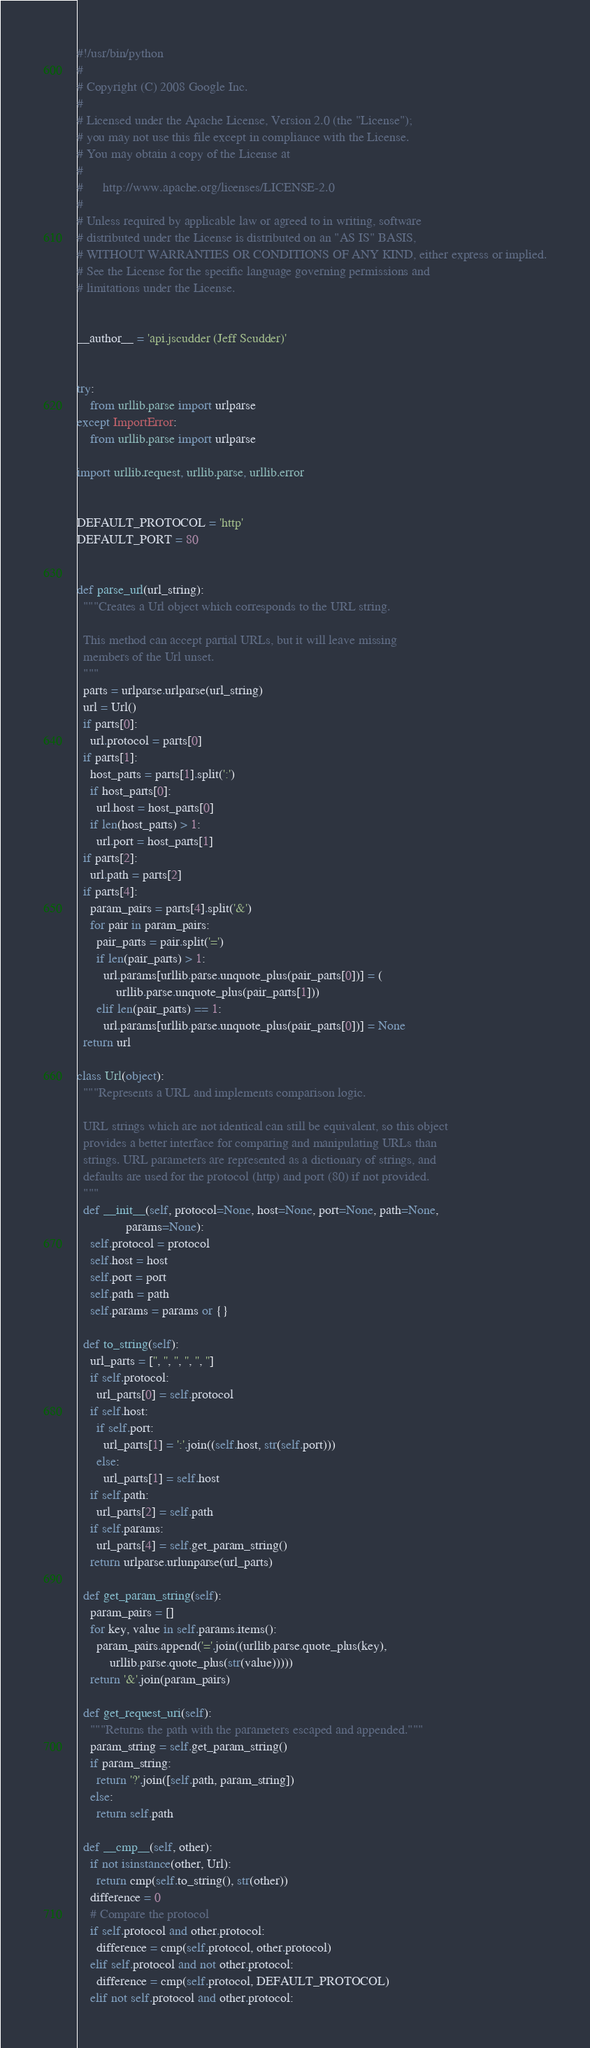<code> <loc_0><loc_0><loc_500><loc_500><_Python_>#!/usr/bin/python
#
# Copyright (C) 2008 Google Inc.
#
# Licensed under the Apache License, Version 2.0 (the "License");
# you may not use this file except in compliance with the License.
# You may obtain a copy of the License at
#
#      http://www.apache.org/licenses/LICENSE-2.0
#
# Unless required by applicable law or agreed to in writing, software
# distributed under the License is distributed on an "AS IS" BASIS,
# WITHOUT WARRANTIES OR CONDITIONS OF ANY KIND, either express or implied.
# See the License for the specific language governing permissions and
# limitations under the License.


__author__ = 'api.jscudder (Jeff Scudder)'


try:
    from urllib.parse import urlparse
except ImportError:
    from urllib.parse import urlparse

import urllib.request, urllib.parse, urllib.error


DEFAULT_PROTOCOL = 'http'
DEFAULT_PORT = 80


def parse_url(url_string):
  """Creates a Url object which corresponds to the URL string.
  
  This method can accept partial URLs, but it will leave missing
  members of the Url unset.
  """
  parts = urlparse.urlparse(url_string)
  url = Url()
  if parts[0]:
    url.protocol = parts[0]
  if parts[1]:
    host_parts = parts[1].split(':')
    if host_parts[0]:
      url.host = host_parts[0]
    if len(host_parts) > 1:
      url.port = host_parts[1]
  if parts[2]:
    url.path = parts[2]
  if parts[4]:
    param_pairs = parts[4].split('&')
    for pair in param_pairs:
      pair_parts = pair.split('=')
      if len(pair_parts) > 1:
        url.params[urllib.parse.unquote_plus(pair_parts[0])] = (
            urllib.parse.unquote_plus(pair_parts[1]))
      elif len(pair_parts) == 1:
        url.params[urllib.parse.unquote_plus(pair_parts[0])] = None
  return url
   
class Url(object):
  """Represents a URL and implements comparison logic.
  
  URL strings which are not identical can still be equivalent, so this object
  provides a better interface for comparing and manipulating URLs than 
  strings. URL parameters are represented as a dictionary of strings, and
  defaults are used for the protocol (http) and port (80) if not provided.
  """
  def __init__(self, protocol=None, host=None, port=None, path=None, 
               params=None):
    self.protocol = protocol
    self.host = host
    self.port = port
    self.path = path
    self.params = params or {}

  def to_string(self):
    url_parts = ['', '', '', '', '', '']
    if self.protocol:
      url_parts[0] = self.protocol
    if self.host:
      if self.port:
        url_parts[1] = ':'.join((self.host, str(self.port)))
      else:
        url_parts[1] = self.host
    if self.path:
      url_parts[2] = self.path
    if self.params:
      url_parts[4] = self.get_param_string()
    return urlparse.urlunparse(url_parts)

  def get_param_string(self):
    param_pairs = []
    for key, value in self.params.items():
      param_pairs.append('='.join((urllib.parse.quote_plus(key), 
          urllib.parse.quote_plus(str(value)))))
    return '&'.join(param_pairs)

  def get_request_uri(self):
    """Returns the path with the parameters escaped and appended."""
    param_string = self.get_param_string()
    if param_string:
      return '?'.join([self.path, param_string])
    else:
      return self.path

  def __cmp__(self, other):
    if not isinstance(other, Url):
      return cmp(self.to_string(), str(other))
    difference = 0
    # Compare the protocol
    if self.protocol and other.protocol:
      difference = cmp(self.protocol, other.protocol)
    elif self.protocol and not other.protocol:
      difference = cmp(self.protocol, DEFAULT_PROTOCOL)
    elif not self.protocol and other.protocol:</code> 